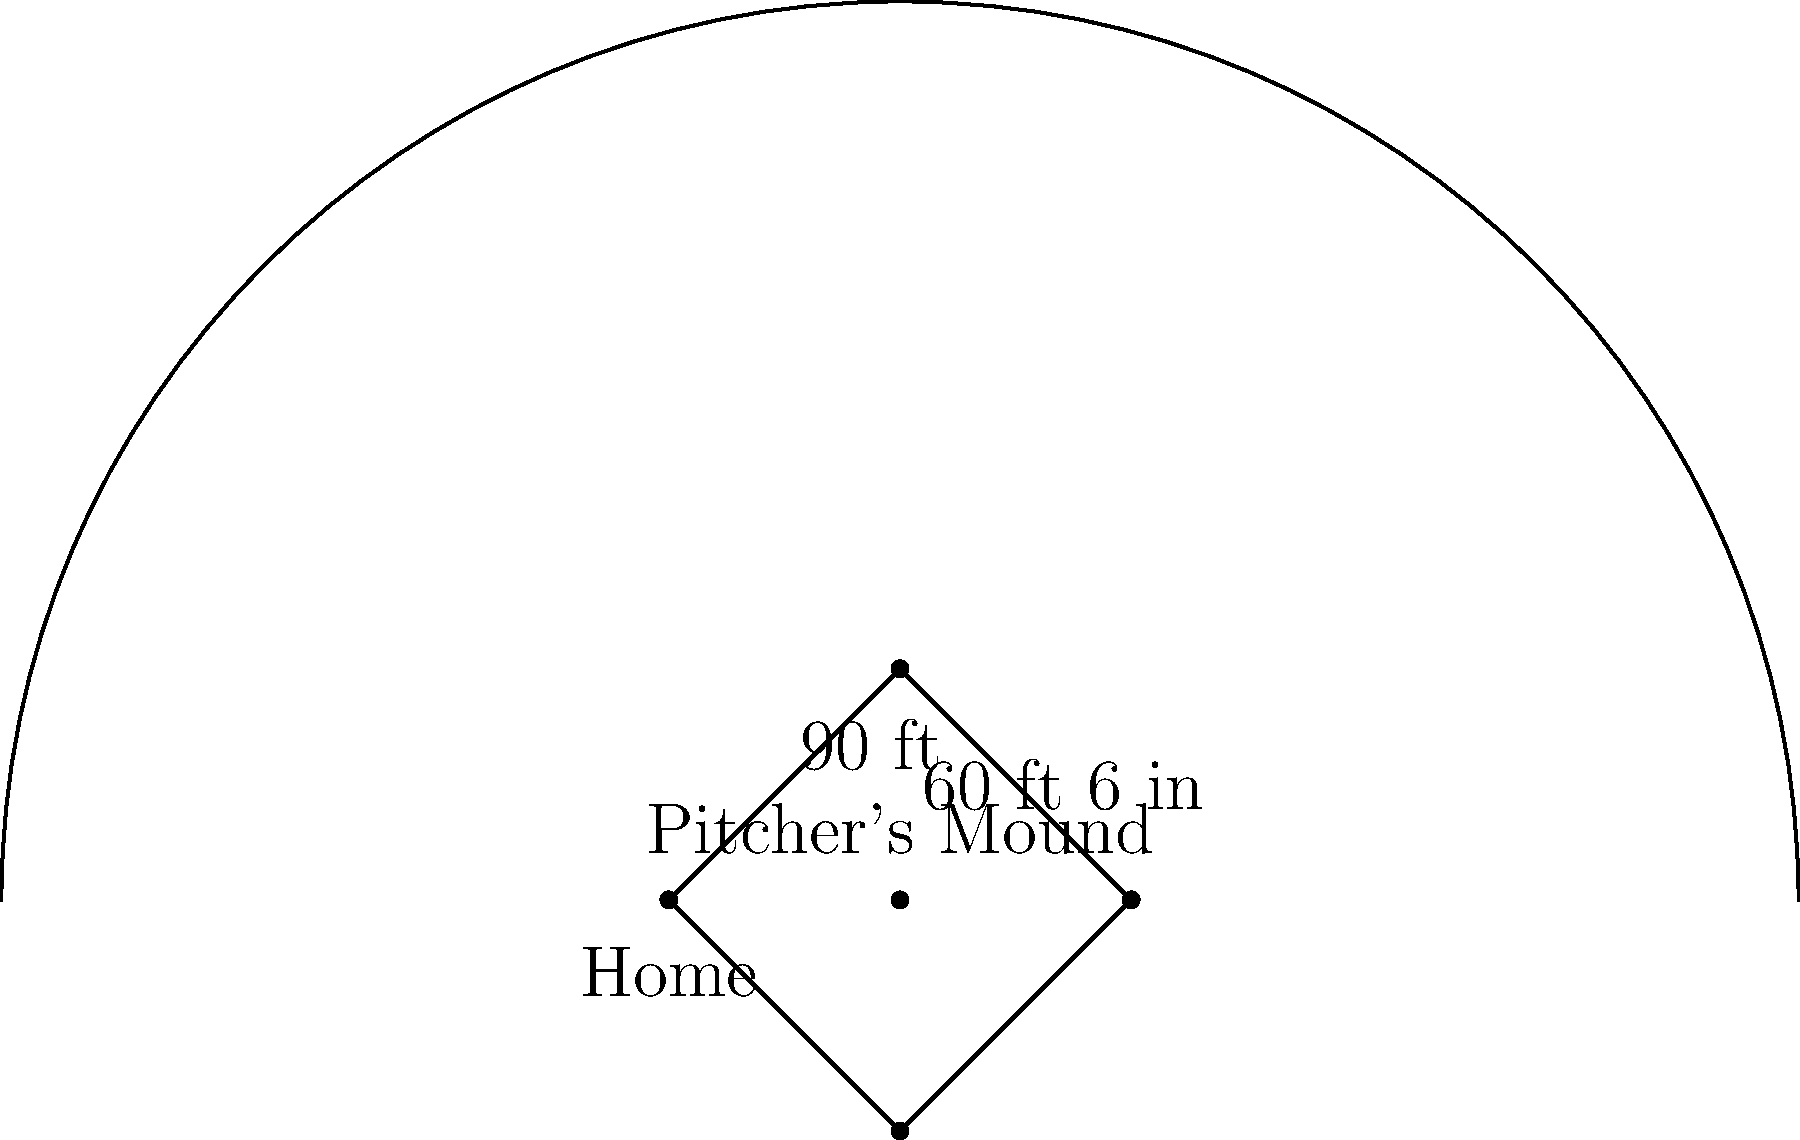As a physical education teacher encouraging students to join the baseball team, you need to ensure they understand the basic layout of a baseball field. In the diagram above, what is the distance between home plate and the pitcher's mound? To answer this question, let's break down the key elements of a standard baseball field layout:

1. The baseball diamond is a square with 90-foot sides.
2. Home plate is located at one corner of the diamond.
3. The pitcher's mound is positioned in the center of the diamond.
4. The distance from home plate to the pitcher's mound is a crucial measurement in baseball.

In the diagram, we can see a label indicating "60 ft 6 in" pointing from home plate to the pitcher's mound. This is the standard distance in professional and most amateur baseball games.

It's important to note that:
- This distance is measured from the front of the pitcher's rubber to the apex of home plate.
- The 60 feet 6 inches (or 18.39 meters) distance has been the standard in Major League Baseball since 1893.
- Understanding this distance is crucial for pitchers to develop proper throwing mechanics and for batters to time their swings correctly.

As a physical education teacher, emphasizing this standard measurement can help students appreciate the precision involved in the sport and how it affects gameplay.
Answer: 60 feet 6 inches 